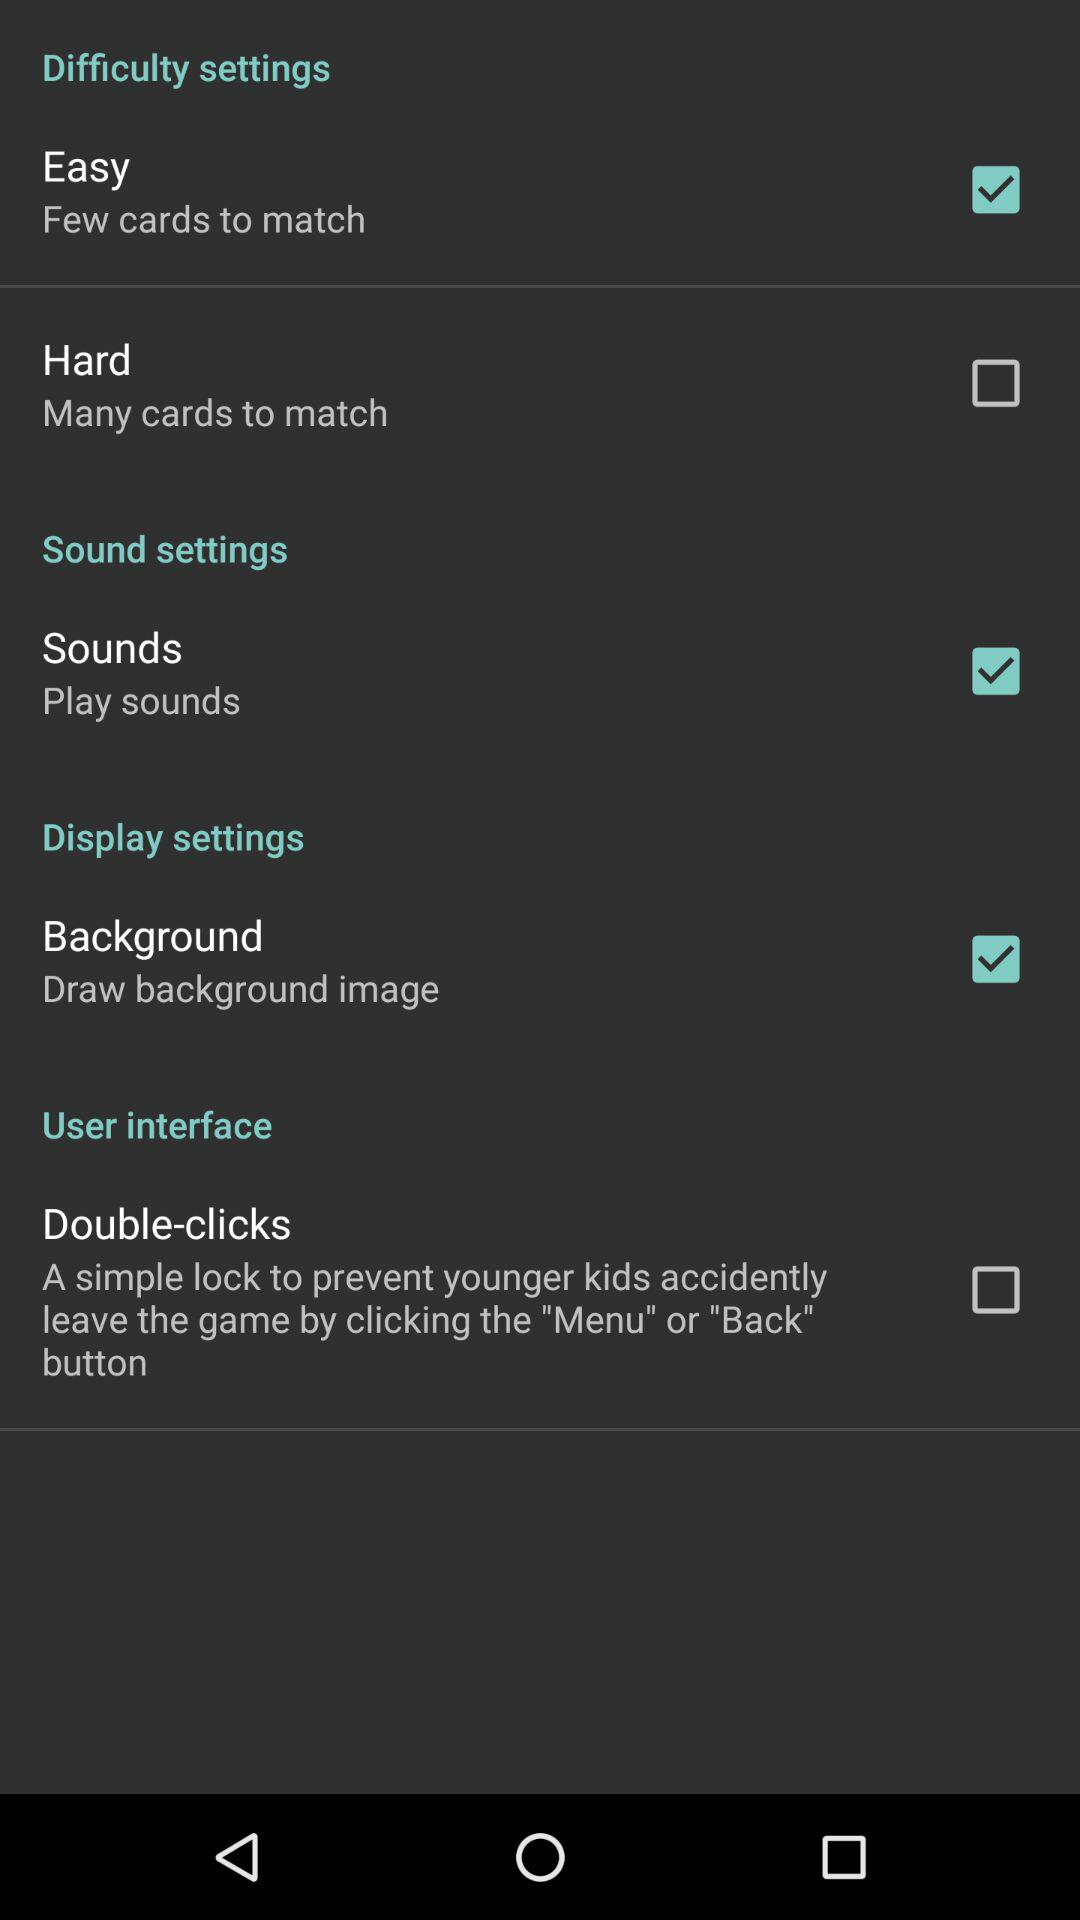How many difficulty settings are there?
Answer the question using a single word or phrase. 2 